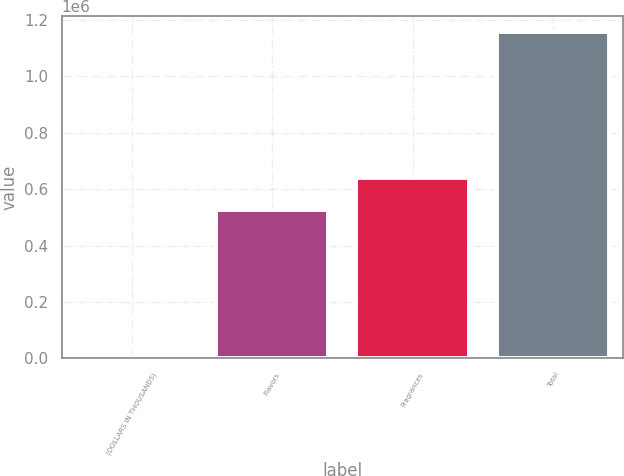<chart> <loc_0><loc_0><loc_500><loc_500><bar_chart><fcel>(DOLLARS IN THOUSANDS)<fcel>Flavors<fcel>Fragrances<fcel>Total<nl><fcel>2017<fcel>525038<fcel>640465<fcel>1.15629e+06<nl></chart> 